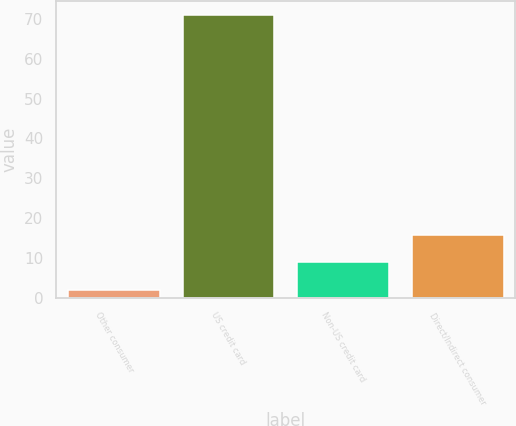<chart> <loc_0><loc_0><loc_500><loc_500><bar_chart><fcel>Other consumer<fcel>US credit card<fcel>Non-US credit card<fcel>Direct/Indirect consumer<nl><fcel>2<fcel>71<fcel>8.9<fcel>15.8<nl></chart> 